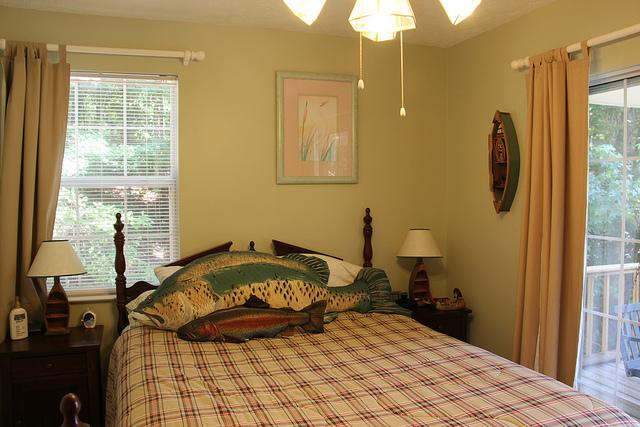What type of food is the animal on the bed classified as? Please explain your reasoning. seafood. The other options don't match a salmon, which is a fish. 